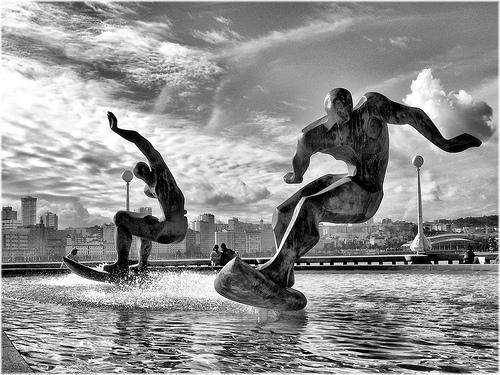How many statues are in the water?
Give a very brief answer. 2. How many street lamps are in the photo?
Give a very brief answer. 2. 